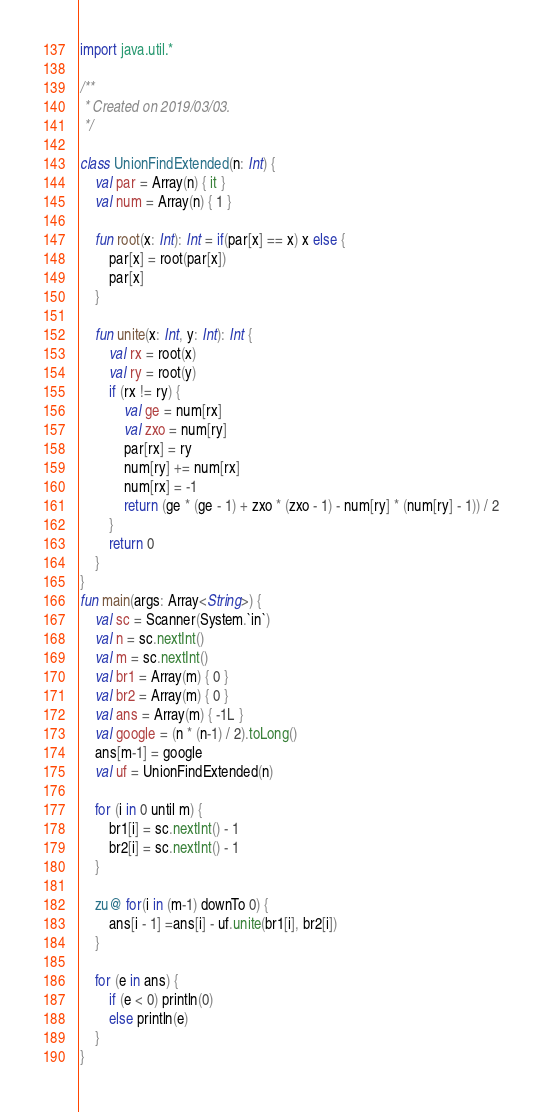Convert code to text. <code><loc_0><loc_0><loc_500><loc_500><_Kotlin_>import java.util.*

/**
 * Created on 2019/03/03.
 */

class UnionFindExtended(n: Int) {
    val par = Array(n) { it }
    val num = Array(n) { 1 }

    fun root(x: Int): Int = if(par[x] == x) x else {
        par[x] = root(par[x])
        par[x]
    }

    fun unite(x: Int, y: Int): Int {
        val rx = root(x)
        val ry = root(y)
        if (rx != ry) {
            val ge = num[rx]
            val zxo = num[ry]
            par[rx] = ry
            num[ry] += num[rx]
            num[rx] = -1
            return (ge * (ge - 1) + zxo * (zxo - 1) - num[ry] * (num[ry] - 1)) / 2
        }
        return 0
    }
}
fun main(args: Array<String>) {
    val sc = Scanner(System.`in`)
    val n = sc.nextInt()
    val m = sc.nextInt()
    val br1 = Array(m) { 0 }
    val br2 = Array(m) { 0 }
    val ans = Array(m) { -1L }
    val google = (n * (n-1) / 2).toLong()
    ans[m-1] = google
    val uf = UnionFindExtended(n)

    for (i in 0 until m) {
        br1[i] = sc.nextInt() - 1
        br2[i] = sc.nextInt() - 1
    }

    zu@ for(i in (m-1) downTo 0) {
        ans[i - 1] =ans[i] - uf.unite(br1[i], br2[i])
    }

    for (e in ans) {
        if (e < 0) println(0)
        else println(e)
    }
}
</code> 